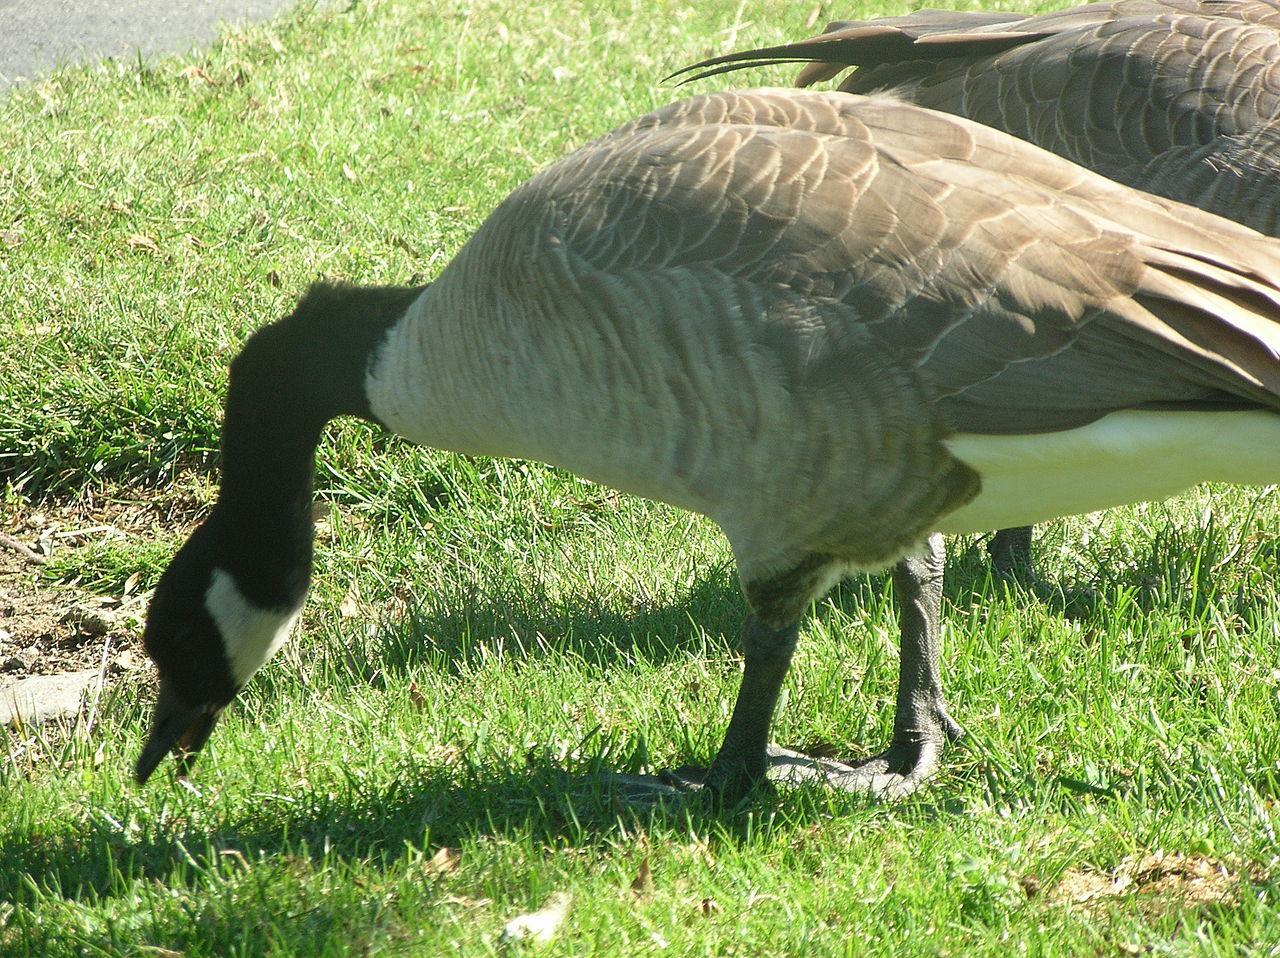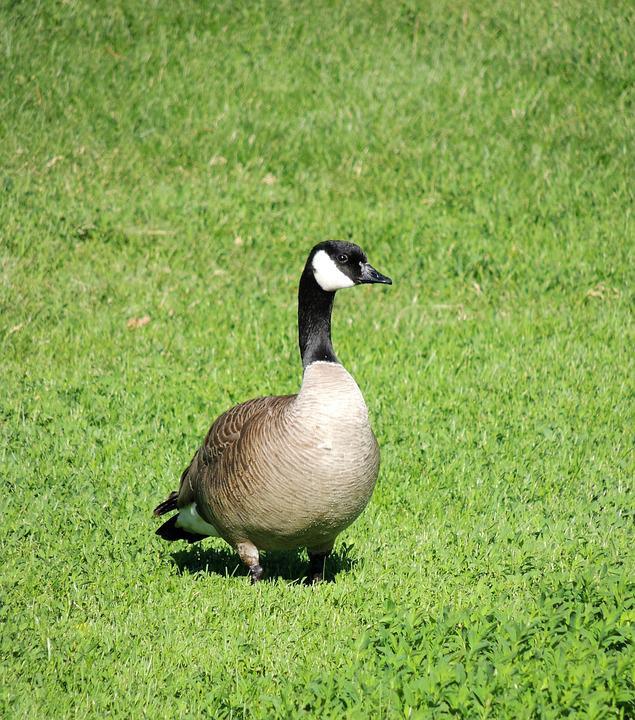The first image is the image on the left, the second image is the image on the right. Considering the images on both sides, is "Each image contains one black-necked goose, and each goose has its neck bent so its beak points downward." valid? Answer yes or no. No. The first image is the image on the left, the second image is the image on the right. Evaluate the accuracy of this statement regarding the images: "The duck in the right image has its beak on the ground.". Is it true? Answer yes or no. No. 